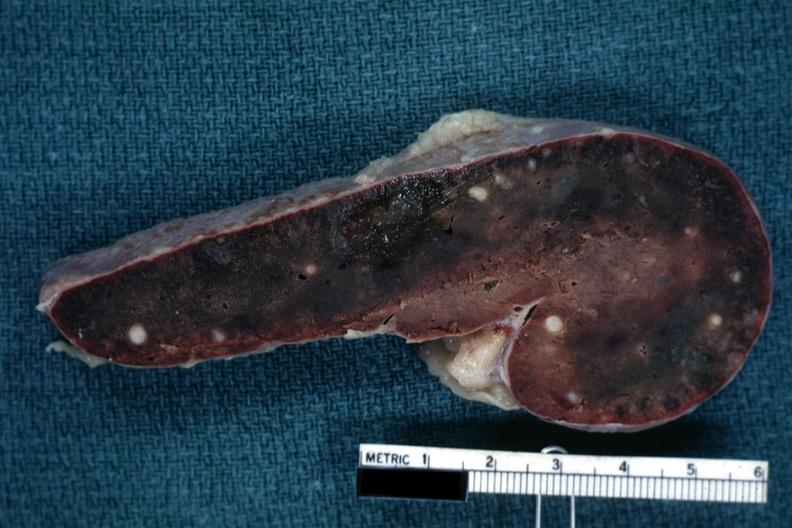s adenocarcinoma present?
Answer the question using a single word or phrase. No 